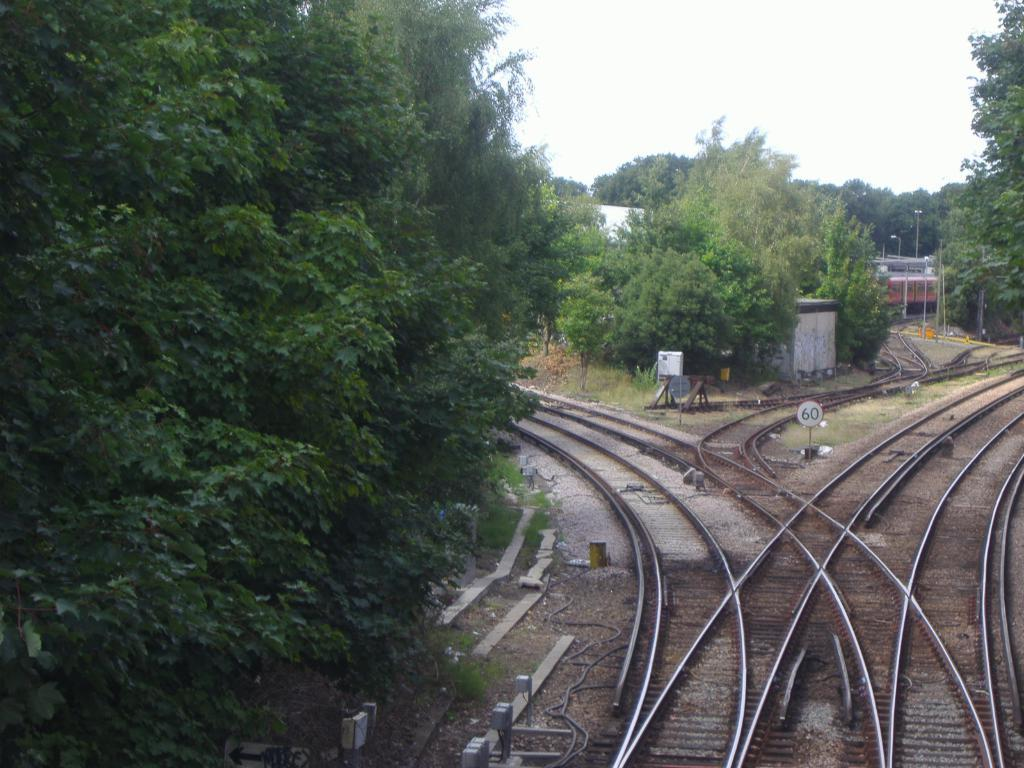What can be seen on the right side of the image? There are railway tracks on the right side of the image. What is near the railway tracks? There is a board with a number near the railway tracks. What type of vegetation is on the left side of the image? There are trees on the left side of the image. What is visible in the background of the image? There are trees and the sky visible in the background of the image. Can you tell me how many balloons are tied to the partner's hand in the image? There are no balloons or partners present in the image. What type of pain is the person experiencing in the image? There is no person experiencing pain in the image. 